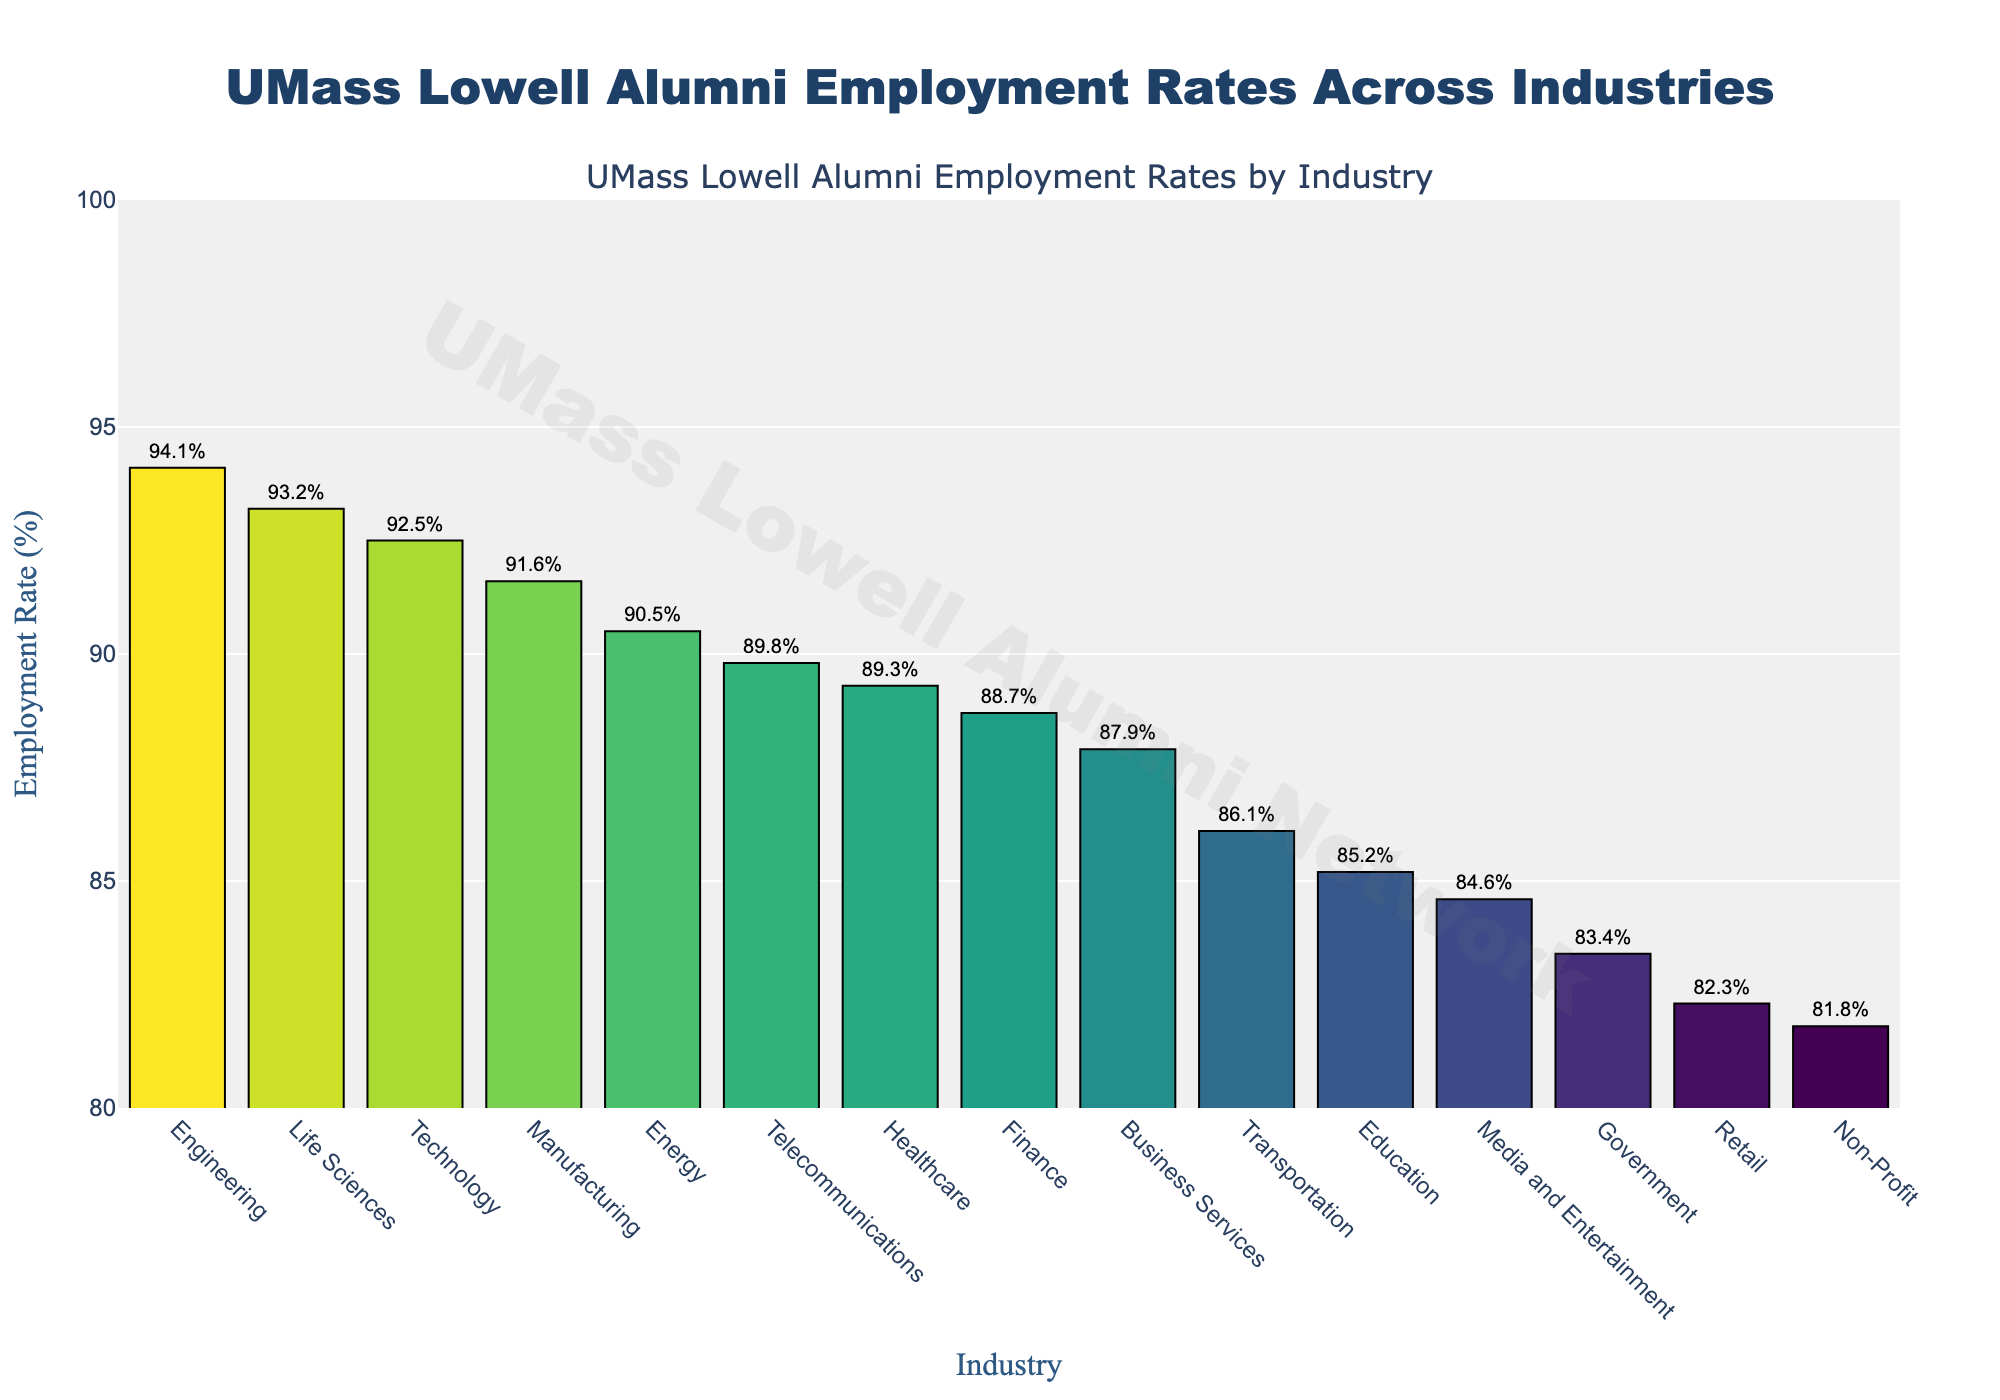What is the employment rate in the Technology industry for UMass Lowell alumni? The bar chart indicates specific employment rates for each industry, so we can directly refer to it for the Technology industry. The employment rate is marked next to the respective bar.
Answer: 92.5% How much higher is the employment rate in Engineering compared to Retail? To find this, we subtract the employment rate of Retail (82.3%) from that of Engineering (94.1%). 94.1% - 82.3% = 11.8%.
Answer: 11.8% Which industry has the lowest employment rate for UMass Lowell alumni? By examining the heights of the bars in the figure, the Non-Profit industry has the shortest bar, indicating the lowest employment rate.
Answer: Non-Profit What is the average employment rate across all industries shown in the figure? To calculate the average, sum all the employment rates and then divide by the number of industries. Sum = 92.5 + 89.3 + 94.1 + 88.7 + 85.2 + 91.6 + 87.9 + 83.4 + 81.8 + 93.2 + 90.5 + 89.8 + 84.6 + 82.3 + 86.1 = 1320.
Answer: 1320 / 15 ≈ 88% Between Healthcare and Telecommunications, which industry has a higher employment rate and by how much? Telecommunications has an employment rate of 89.8%, and Healthcare has 89.3%. The difference is 89.8% - 89.3% = 0.5%.
Answer: Telecommunications by 0.5% What is the median employment rate of the industries listed? To find the median, first order the employment rates from smallest to largest and then identify the middle value. Ordered: 81.8, 82.3, 83.4, 84.6, 85.2, 86.1, 87.9, 88.7, 89.3, 89.8, 90.5, 91.6, 92.5, 93.2, 94.1. The median is the 8th value: 88.7%.
Answer: 88.7% Which industry has an employment rate closest to 90%? Comparing the employment rates to 90%, the closest ones are Telecommunications (89.8%) and Energy (90.5%). Energy is closer since the difference is only 0.5%.
Answer: Energy How many industries have an employment rate of 90% or higher? By reviewing the bars with employment rates of 90% or higher: Technology, Engineering, Life Sciences, Energy, and Manufacturing.
Answer: 5 Is the employment rate in the Business Services industry higher or lower than in Education? Business Services has an employment rate of 87.9%, and Education has 85.2%. Business Services is higher.
Answer: Higher 